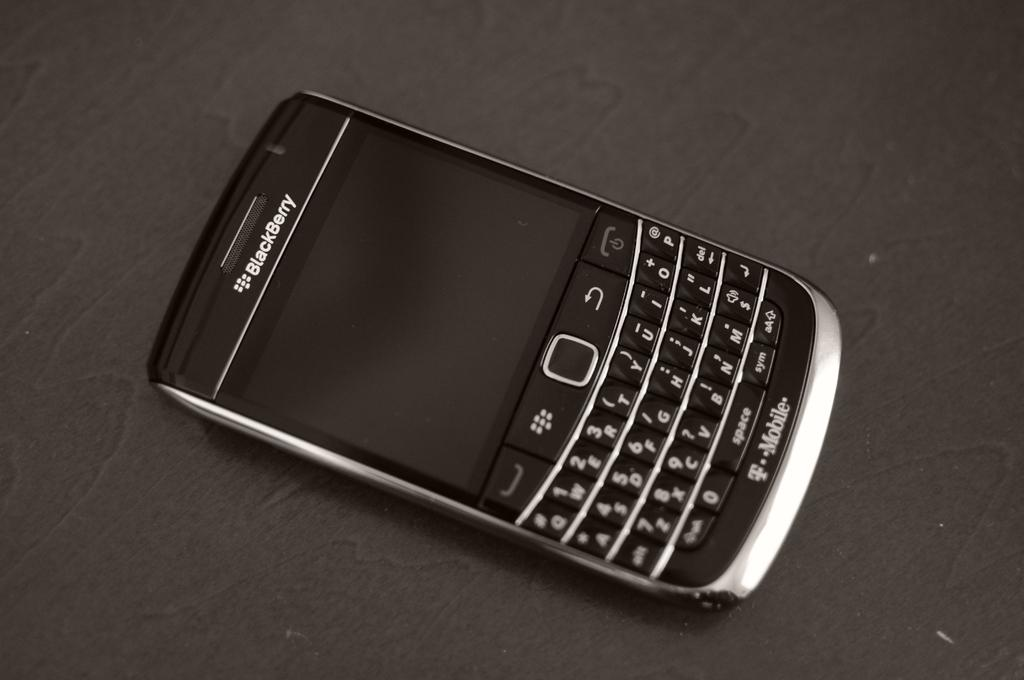Provide a one-sentence caption for the provided image. A T Mobile Blackberry phone sits on a table showing a blank screen and a complete QWERTY keyboard. 